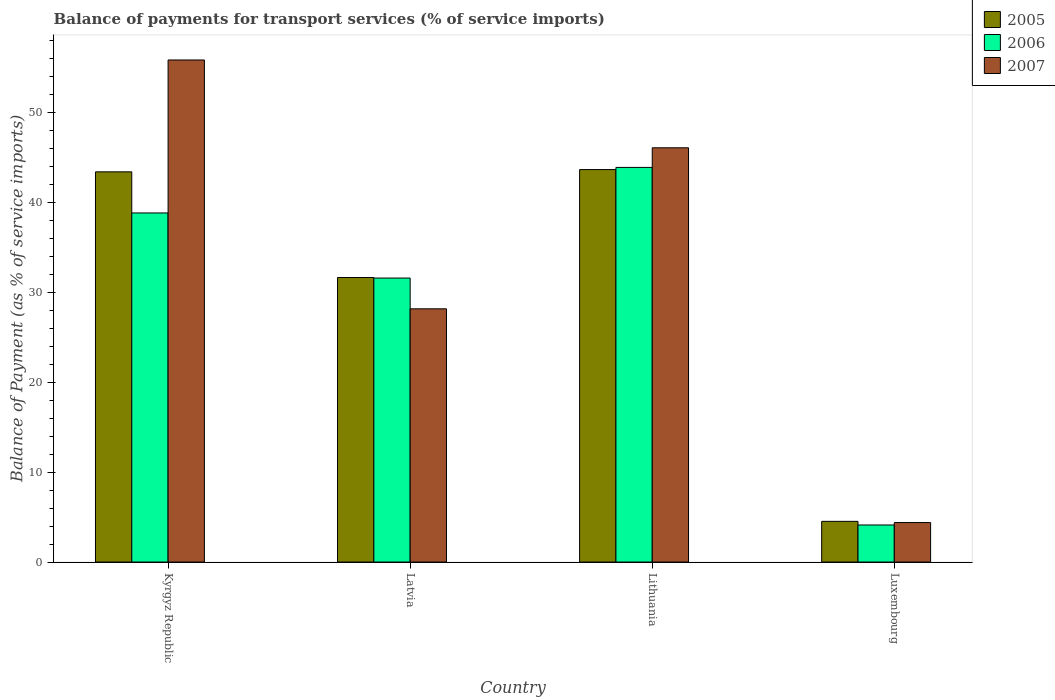Are the number of bars per tick equal to the number of legend labels?
Give a very brief answer. Yes. How many bars are there on the 3rd tick from the left?
Keep it short and to the point. 3. How many bars are there on the 4th tick from the right?
Your answer should be compact. 3. What is the label of the 2nd group of bars from the left?
Offer a terse response. Latvia. In how many cases, is the number of bars for a given country not equal to the number of legend labels?
Ensure brevity in your answer.  0. What is the balance of payments for transport services in 2007 in Kyrgyz Republic?
Provide a short and direct response. 55.85. Across all countries, what is the maximum balance of payments for transport services in 2005?
Offer a very short reply. 43.66. Across all countries, what is the minimum balance of payments for transport services in 2005?
Offer a very short reply. 4.53. In which country was the balance of payments for transport services in 2007 maximum?
Your response must be concise. Kyrgyz Republic. In which country was the balance of payments for transport services in 2005 minimum?
Ensure brevity in your answer.  Luxembourg. What is the total balance of payments for transport services in 2006 in the graph?
Provide a succinct answer. 118.44. What is the difference between the balance of payments for transport services in 2006 in Kyrgyz Republic and that in Latvia?
Give a very brief answer. 7.24. What is the difference between the balance of payments for transport services in 2006 in Latvia and the balance of payments for transport services in 2007 in Kyrgyz Republic?
Keep it short and to the point. -24.26. What is the average balance of payments for transport services in 2005 per country?
Provide a short and direct response. 30.81. What is the difference between the balance of payments for transport services of/in 2006 and balance of payments for transport services of/in 2005 in Luxembourg?
Your response must be concise. -0.4. In how many countries, is the balance of payments for transport services in 2006 greater than 22 %?
Offer a very short reply. 3. What is the ratio of the balance of payments for transport services in 2005 in Kyrgyz Republic to that in Lithuania?
Keep it short and to the point. 0.99. What is the difference between the highest and the second highest balance of payments for transport services in 2007?
Provide a short and direct response. -17.91. What is the difference between the highest and the lowest balance of payments for transport services in 2007?
Offer a very short reply. 51.46. Is the sum of the balance of payments for transport services in 2006 in Latvia and Luxembourg greater than the maximum balance of payments for transport services in 2005 across all countries?
Offer a very short reply. No. What does the 3rd bar from the left in Kyrgyz Republic represents?
Your response must be concise. 2007. What does the 1st bar from the right in Lithuania represents?
Provide a succinct answer. 2007. Is it the case that in every country, the sum of the balance of payments for transport services in 2007 and balance of payments for transport services in 2005 is greater than the balance of payments for transport services in 2006?
Your answer should be very brief. Yes. Are all the bars in the graph horizontal?
Offer a terse response. No. What is the title of the graph?
Provide a short and direct response. Balance of payments for transport services (% of service imports). What is the label or title of the X-axis?
Offer a terse response. Country. What is the label or title of the Y-axis?
Provide a succinct answer. Balance of Payment (as % of service imports). What is the Balance of Payment (as % of service imports) in 2005 in Kyrgyz Republic?
Make the answer very short. 43.41. What is the Balance of Payment (as % of service imports) in 2006 in Kyrgyz Republic?
Your answer should be compact. 38.83. What is the Balance of Payment (as % of service imports) of 2007 in Kyrgyz Republic?
Offer a very short reply. 55.85. What is the Balance of Payment (as % of service imports) in 2005 in Latvia?
Your answer should be compact. 31.65. What is the Balance of Payment (as % of service imports) in 2006 in Latvia?
Make the answer very short. 31.59. What is the Balance of Payment (as % of service imports) in 2007 in Latvia?
Offer a terse response. 28.17. What is the Balance of Payment (as % of service imports) of 2005 in Lithuania?
Your answer should be compact. 43.66. What is the Balance of Payment (as % of service imports) in 2006 in Lithuania?
Your response must be concise. 43.9. What is the Balance of Payment (as % of service imports) of 2007 in Lithuania?
Provide a succinct answer. 46.08. What is the Balance of Payment (as % of service imports) of 2005 in Luxembourg?
Ensure brevity in your answer.  4.53. What is the Balance of Payment (as % of service imports) of 2006 in Luxembourg?
Your response must be concise. 4.12. What is the Balance of Payment (as % of service imports) of 2007 in Luxembourg?
Ensure brevity in your answer.  4.39. Across all countries, what is the maximum Balance of Payment (as % of service imports) of 2005?
Provide a succinct answer. 43.66. Across all countries, what is the maximum Balance of Payment (as % of service imports) of 2006?
Make the answer very short. 43.9. Across all countries, what is the maximum Balance of Payment (as % of service imports) in 2007?
Keep it short and to the point. 55.85. Across all countries, what is the minimum Balance of Payment (as % of service imports) in 2005?
Ensure brevity in your answer.  4.53. Across all countries, what is the minimum Balance of Payment (as % of service imports) in 2006?
Your answer should be compact. 4.12. Across all countries, what is the minimum Balance of Payment (as % of service imports) of 2007?
Make the answer very short. 4.39. What is the total Balance of Payment (as % of service imports) in 2005 in the graph?
Your answer should be very brief. 123.24. What is the total Balance of Payment (as % of service imports) of 2006 in the graph?
Your answer should be compact. 118.44. What is the total Balance of Payment (as % of service imports) of 2007 in the graph?
Your response must be concise. 134.49. What is the difference between the Balance of Payment (as % of service imports) in 2005 in Kyrgyz Republic and that in Latvia?
Provide a short and direct response. 11.75. What is the difference between the Balance of Payment (as % of service imports) of 2006 in Kyrgyz Republic and that in Latvia?
Your answer should be compact. 7.24. What is the difference between the Balance of Payment (as % of service imports) in 2007 in Kyrgyz Republic and that in Latvia?
Ensure brevity in your answer.  27.68. What is the difference between the Balance of Payment (as % of service imports) in 2005 in Kyrgyz Republic and that in Lithuania?
Provide a succinct answer. -0.25. What is the difference between the Balance of Payment (as % of service imports) in 2006 in Kyrgyz Republic and that in Lithuania?
Offer a terse response. -5.07. What is the difference between the Balance of Payment (as % of service imports) in 2007 in Kyrgyz Republic and that in Lithuania?
Provide a short and direct response. 9.77. What is the difference between the Balance of Payment (as % of service imports) of 2005 in Kyrgyz Republic and that in Luxembourg?
Give a very brief answer. 38.88. What is the difference between the Balance of Payment (as % of service imports) in 2006 in Kyrgyz Republic and that in Luxembourg?
Offer a terse response. 34.71. What is the difference between the Balance of Payment (as % of service imports) of 2007 in Kyrgyz Republic and that in Luxembourg?
Your response must be concise. 51.46. What is the difference between the Balance of Payment (as % of service imports) of 2005 in Latvia and that in Lithuania?
Your answer should be very brief. -12.01. What is the difference between the Balance of Payment (as % of service imports) in 2006 in Latvia and that in Lithuania?
Give a very brief answer. -12.31. What is the difference between the Balance of Payment (as % of service imports) in 2007 in Latvia and that in Lithuania?
Offer a very short reply. -17.91. What is the difference between the Balance of Payment (as % of service imports) of 2005 in Latvia and that in Luxembourg?
Your answer should be very brief. 27.13. What is the difference between the Balance of Payment (as % of service imports) of 2006 in Latvia and that in Luxembourg?
Give a very brief answer. 27.47. What is the difference between the Balance of Payment (as % of service imports) of 2007 in Latvia and that in Luxembourg?
Keep it short and to the point. 23.78. What is the difference between the Balance of Payment (as % of service imports) of 2005 in Lithuania and that in Luxembourg?
Ensure brevity in your answer.  39.13. What is the difference between the Balance of Payment (as % of service imports) in 2006 in Lithuania and that in Luxembourg?
Keep it short and to the point. 39.78. What is the difference between the Balance of Payment (as % of service imports) in 2007 in Lithuania and that in Luxembourg?
Your answer should be compact. 41.69. What is the difference between the Balance of Payment (as % of service imports) in 2005 in Kyrgyz Republic and the Balance of Payment (as % of service imports) in 2006 in Latvia?
Provide a succinct answer. 11.81. What is the difference between the Balance of Payment (as % of service imports) of 2005 in Kyrgyz Republic and the Balance of Payment (as % of service imports) of 2007 in Latvia?
Give a very brief answer. 15.24. What is the difference between the Balance of Payment (as % of service imports) in 2006 in Kyrgyz Republic and the Balance of Payment (as % of service imports) in 2007 in Latvia?
Provide a short and direct response. 10.66. What is the difference between the Balance of Payment (as % of service imports) of 2005 in Kyrgyz Republic and the Balance of Payment (as % of service imports) of 2006 in Lithuania?
Offer a very short reply. -0.49. What is the difference between the Balance of Payment (as % of service imports) of 2005 in Kyrgyz Republic and the Balance of Payment (as % of service imports) of 2007 in Lithuania?
Make the answer very short. -2.68. What is the difference between the Balance of Payment (as % of service imports) of 2006 in Kyrgyz Republic and the Balance of Payment (as % of service imports) of 2007 in Lithuania?
Keep it short and to the point. -7.25. What is the difference between the Balance of Payment (as % of service imports) in 2005 in Kyrgyz Republic and the Balance of Payment (as % of service imports) in 2006 in Luxembourg?
Provide a succinct answer. 39.28. What is the difference between the Balance of Payment (as % of service imports) of 2005 in Kyrgyz Republic and the Balance of Payment (as % of service imports) of 2007 in Luxembourg?
Offer a terse response. 39.01. What is the difference between the Balance of Payment (as % of service imports) of 2006 in Kyrgyz Republic and the Balance of Payment (as % of service imports) of 2007 in Luxembourg?
Your response must be concise. 34.44. What is the difference between the Balance of Payment (as % of service imports) of 2005 in Latvia and the Balance of Payment (as % of service imports) of 2006 in Lithuania?
Offer a very short reply. -12.25. What is the difference between the Balance of Payment (as % of service imports) of 2005 in Latvia and the Balance of Payment (as % of service imports) of 2007 in Lithuania?
Make the answer very short. -14.43. What is the difference between the Balance of Payment (as % of service imports) in 2006 in Latvia and the Balance of Payment (as % of service imports) in 2007 in Lithuania?
Provide a succinct answer. -14.49. What is the difference between the Balance of Payment (as % of service imports) in 2005 in Latvia and the Balance of Payment (as % of service imports) in 2006 in Luxembourg?
Provide a succinct answer. 27.53. What is the difference between the Balance of Payment (as % of service imports) in 2005 in Latvia and the Balance of Payment (as % of service imports) in 2007 in Luxembourg?
Offer a very short reply. 27.26. What is the difference between the Balance of Payment (as % of service imports) of 2006 in Latvia and the Balance of Payment (as % of service imports) of 2007 in Luxembourg?
Provide a short and direct response. 27.2. What is the difference between the Balance of Payment (as % of service imports) of 2005 in Lithuania and the Balance of Payment (as % of service imports) of 2006 in Luxembourg?
Your answer should be compact. 39.54. What is the difference between the Balance of Payment (as % of service imports) in 2005 in Lithuania and the Balance of Payment (as % of service imports) in 2007 in Luxembourg?
Your answer should be compact. 39.27. What is the difference between the Balance of Payment (as % of service imports) in 2006 in Lithuania and the Balance of Payment (as % of service imports) in 2007 in Luxembourg?
Provide a succinct answer. 39.51. What is the average Balance of Payment (as % of service imports) in 2005 per country?
Offer a terse response. 30.81. What is the average Balance of Payment (as % of service imports) of 2006 per country?
Provide a succinct answer. 29.61. What is the average Balance of Payment (as % of service imports) of 2007 per country?
Ensure brevity in your answer.  33.62. What is the difference between the Balance of Payment (as % of service imports) in 2005 and Balance of Payment (as % of service imports) in 2006 in Kyrgyz Republic?
Ensure brevity in your answer.  4.57. What is the difference between the Balance of Payment (as % of service imports) of 2005 and Balance of Payment (as % of service imports) of 2007 in Kyrgyz Republic?
Give a very brief answer. -12.44. What is the difference between the Balance of Payment (as % of service imports) in 2006 and Balance of Payment (as % of service imports) in 2007 in Kyrgyz Republic?
Make the answer very short. -17.02. What is the difference between the Balance of Payment (as % of service imports) of 2005 and Balance of Payment (as % of service imports) of 2006 in Latvia?
Give a very brief answer. 0.06. What is the difference between the Balance of Payment (as % of service imports) of 2005 and Balance of Payment (as % of service imports) of 2007 in Latvia?
Your response must be concise. 3.48. What is the difference between the Balance of Payment (as % of service imports) in 2006 and Balance of Payment (as % of service imports) in 2007 in Latvia?
Ensure brevity in your answer.  3.42. What is the difference between the Balance of Payment (as % of service imports) of 2005 and Balance of Payment (as % of service imports) of 2006 in Lithuania?
Give a very brief answer. -0.24. What is the difference between the Balance of Payment (as % of service imports) in 2005 and Balance of Payment (as % of service imports) in 2007 in Lithuania?
Your answer should be very brief. -2.42. What is the difference between the Balance of Payment (as % of service imports) of 2006 and Balance of Payment (as % of service imports) of 2007 in Lithuania?
Your response must be concise. -2.18. What is the difference between the Balance of Payment (as % of service imports) in 2005 and Balance of Payment (as % of service imports) in 2006 in Luxembourg?
Provide a short and direct response. 0.4. What is the difference between the Balance of Payment (as % of service imports) in 2005 and Balance of Payment (as % of service imports) in 2007 in Luxembourg?
Your answer should be very brief. 0.13. What is the difference between the Balance of Payment (as % of service imports) in 2006 and Balance of Payment (as % of service imports) in 2007 in Luxembourg?
Your response must be concise. -0.27. What is the ratio of the Balance of Payment (as % of service imports) in 2005 in Kyrgyz Republic to that in Latvia?
Your answer should be very brief. 1.37. What is the ratio of the Balance of Payment (as % of service imports) in 2006 in Kyrgyz Republic to that in Latvia?
Ensure brevity in your answer.  1.23. What is the ratio of the Balance of Payment (as % of service imports) in 2007 in Kyrgyz Republic to that in Latvia?
Ensure brevity in your answer.  1.98. What is the ratio of the Balance of Payment (as % of service imports) in 2006 in Kyrgyz Republic to that in Lithuania?
Provide a short and direct response. 0.88. What is the ratio of the Balance of Payment (as % of service imports) in 2007 in Kyrgyz Republic to that in Lithuania?
Provide a short and direct response. 1.21. What is the ratio of the Balance of Payment (as % of service imports) in 2005 in Kyrgyz Republic to that in Luxembourg?
Give a very brief answer. 9.59. What is the ratio of the Balance of Payment (as % of service imports) of 2006 in Kyrgyz Republic to that in Luxembourg?
Make the answer very short. 9.42. What is the ratio of the Balance of Payment (as % of service imports) in 2007 in Kyrgyz Republic to that in Luxembourg?
Provide a succinct answer. 12.72. What is the ratio of the Balance of Payment (as % of service imports) of 2005 in Latvia to that in Lithuania?
Your answer should be very brief. 0.72. What is the ratio of the Balance of Payment (as % of service imports) in 2006 in Latvia to that in Lithuania?
Keep it short and to the point. 0.72. What is the ratio of the Balance of Payment (as % of service imports) in 2007 in Latvia to that in Lithuania?
Your answer should be compact. 0.61. What is the ratio of the Balance of Payment (as % of service imports) of 2005 in Latvia to that in Luxembourg?
Offer a very short reply. 6.99. What is the ratio of the Balance of Payment (as % of service imports) in 2006 in Latvia to that in Luxembourg?
Provide a short and direct response. 7.66. What is the ratio of the Balance of Payment (as % of service imports) in 2007 in Latvia to that in Luxembourg?
Your answer should be very brief. 6.41. What is the ratio of the Balance of Payment (as % of service imports) of 2005 in Lithuania to that in Luxembourg?
Make the answer very short. 9.65. What is the ratio of the Balance of Payment (as % of service imports) in 2006 in Lithuania to that in Luxembourg?
Give a very brief answer. 10.65. What is the ratio of the Balance of Payment (as % of service imports) of 2007 in Lithuania to that in Luxembourg?
Ensure brevity in your answer.  10.49. What is the difference between the highest and the second highest Balance of Payment (as % of service imports) in 2005?
Your response must be concise. 0.25. What is the difference between the highest and the second highest Balance of Payment (as % of service imports) in 2006?
Provide a succinct answer. 5.07. What is the difference between the highest and the second highest Balance of Payment (as % of service imports) of 2007?
Your response must be concise. 9.77. What is the difference between the highest and the lowest Balance of Payment (as % of service imports) in 2005?
Give a very brief answer. 39.13. What is the difference between the highest and the lowest Balance of Payment (as % of service imports) in 2006?
Provide a succinct answer. 39.78. What is the difference between the highest and the lowest Balance of Payment (as % of service imports) of 2007?
Provide a short and direct response. 51.46. 